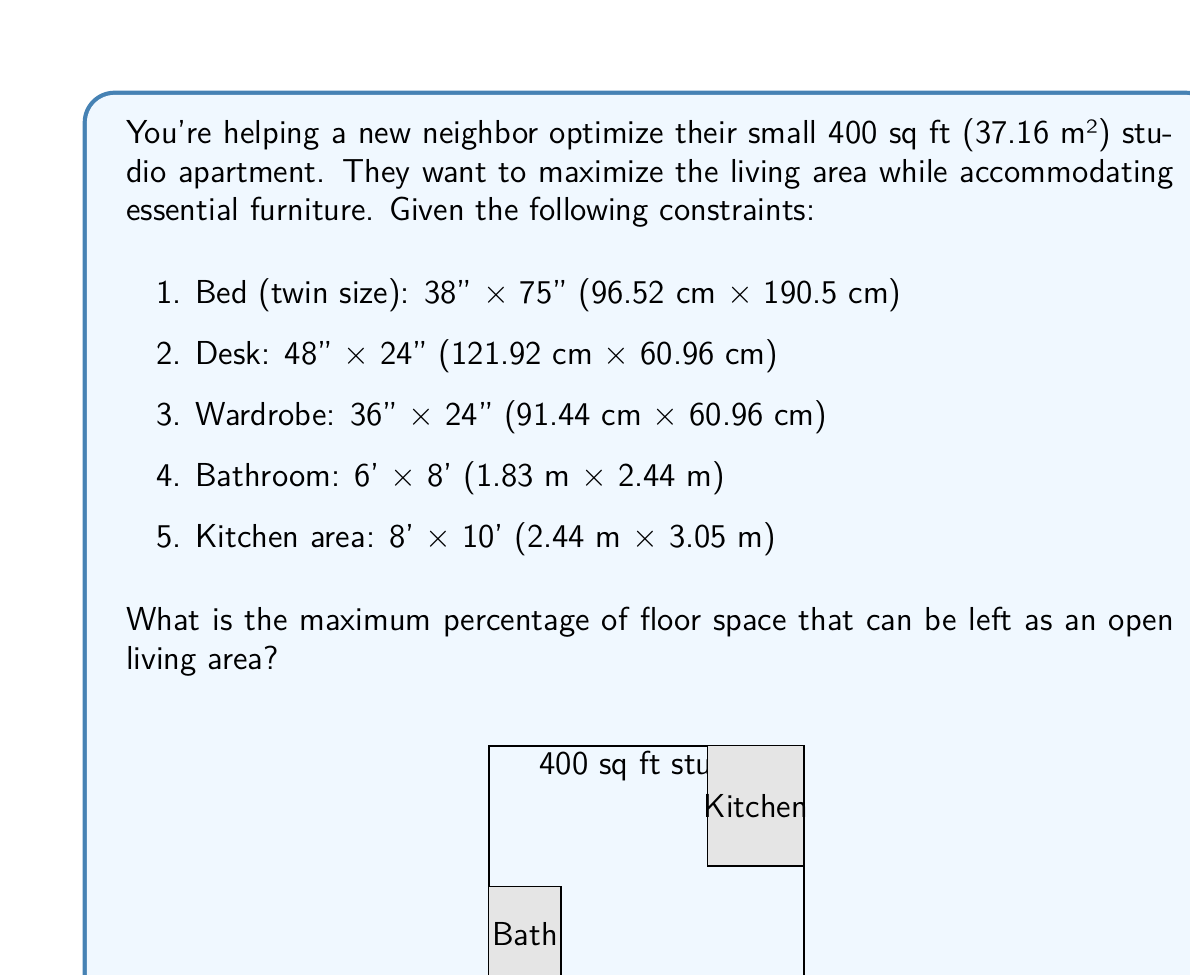Can you solve this math problem? Let's approach this step-by-step:

1) First, calculate the area of each element:
   - Bed: $96.52 \times 190.5 = 18,387.06$ cm² = 1.84 m²
   - Desk: $121.92 \times 60.96 = 7,432.24$ cm² = 0.74 m²
   - Wardrobe: $91.44 \times 60.96 = 5,574.18$ cm² = 0.56 m²
   - Bathroom: $1.83 \times 2.44 = 4.47$ m²
   - Kitchen: $2.44 \times 3.05 = 7.44$ m²

2) Calculate the total area occupied by these elements:
   $$ 1.84 + 0.74 + 0.56 + 4.47 + 7.44 = 15.05 \text{ m²} $$

3) Calculate the remaining area:
   $$ 37.16 \text{ m²} - 15.05 \text{ m²} = 22.11 \text{ m²} $$

4) Calculate the percentage of open living area:
   $$ \frac{22.11 \text{ m²}}{37.16 \text{ m²}} \times 100\% = 59.50\% $$

Therefore, the maximum percentage of floor space that can be left as an open living area is approximately 59.50%.
Answer: 59.50% 